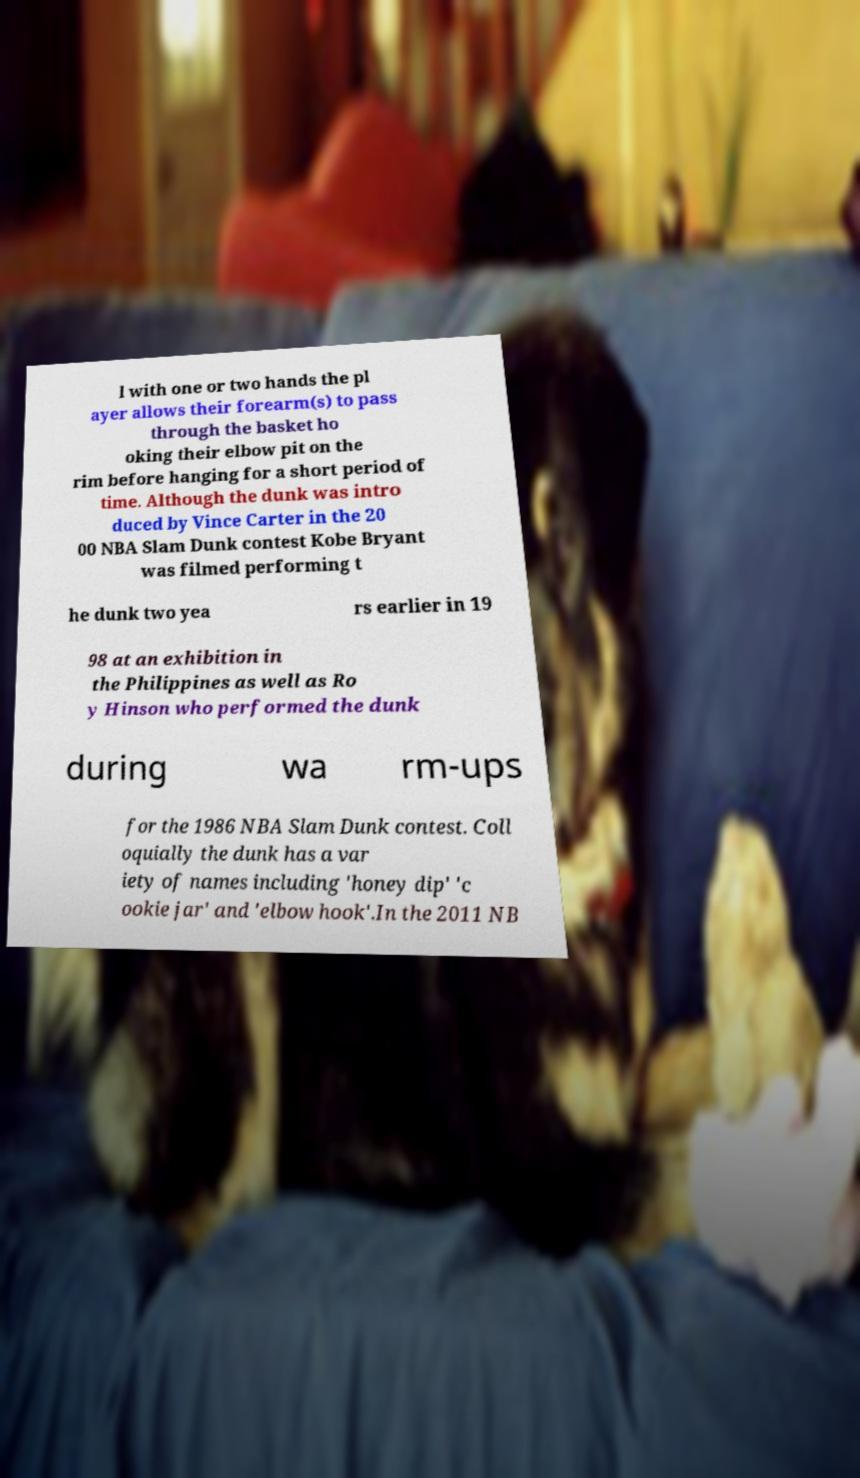What messages or text are displayed in this image? I need them in a readable, typed format. l with one or two hands the pl ayer allows their forearm(s) to pass through the basket ho oking their elbow pit on the rim before hanging for a short period of time. Although the dunk was intro duced by Vince Carter in the 20 00 NBA Slam Dunk contest Kobe Bryant was filmed performing t he dunk two yea rs earlier in 19 98 at an exhibition in the Philippines as well as Ro y Hinson who performed the dunk during wa rm-ups for the 1986 NBA Slam Dunk contest. Coll oquially the dunk has a var iety of names including 'honey dip' 'c ookie jar' and 'elbow hook'.In the 2011 NB 